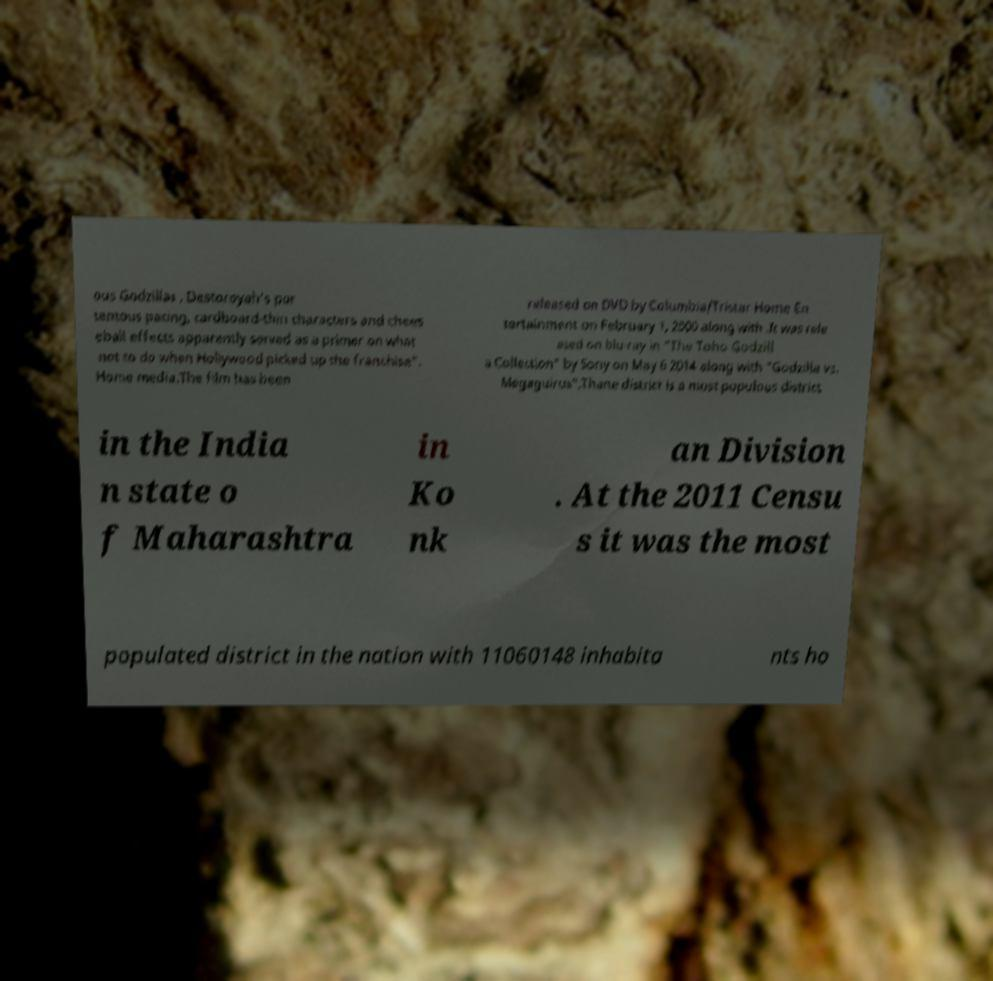Could you assist in decoding the text presented in this image and type it out clearly? ous Godzillas , Destoroyah's por tentous pacing, cardboard-thin characters and chees eball effects apparently served as a primer on what not to do when Hollywood picked up the franchise". Home media.The film has been released on DVD by Columbia/Tristar Home En tertainment on February 1, 2000 along with .It was rele ased on blu-ray in "The Toho Godzill a Collection" by Sony on May 6 2014 along with "Godzilla vs. Megaguirus".Thane district is a most populous district in the India n state o f Maharashtra in Ko nk an Division . At the 2011 Censu s it was the most populated district in the nation with 11060148 inhabita nts ho 